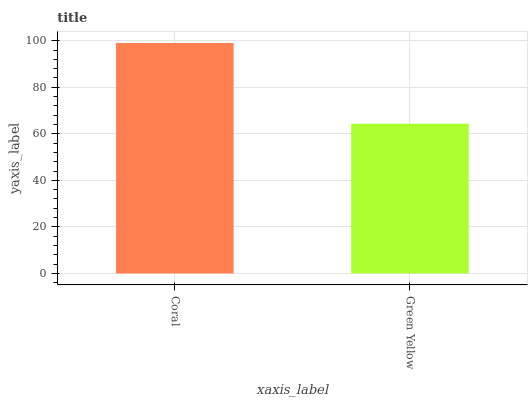Is Green Yellow the minimum?
Answer yes or no. Yes. Is Coral the maximum?
Answer yes or no. Yes. Is Green Yellow the maximum?
Answer yes or no. No. Is Coral greater than Green Yellow?
Answer yes or no. Yes. Is Green Yellow less than Coral?
Answer yes or no. Yes. Is Green Yellow greater than Coral?
Answer yes or no. No. Is Coral less than Green Yellow?
Answer yes or no. No. Is Coral the high median?
Answer yes or no. Yes. Is Green Yellow the low median?
Answer yes or no. Yes. Is Green Yellow the high median?
Answer yes or no. No. Is Coral the low median?
Answer yes or no. No. 